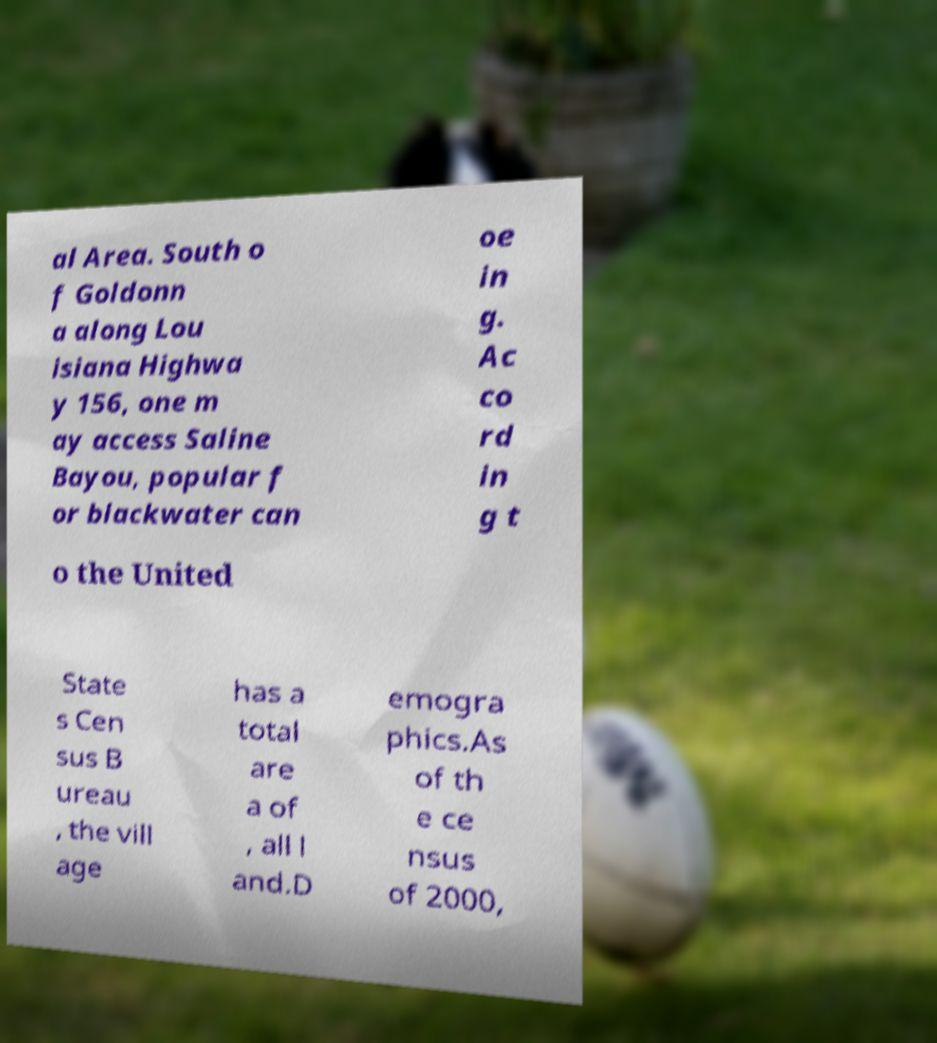Could you extract and type out the text from this image? al Area. South o f Goldonn a along Lou isiana Highwa y 156, one m ay access Saline Bayou, popular f or blackwater can oe in g. Ac co rd in g t o the United State s Cen sus B ureau , the vill age has a total are a of , all l and.D emogra phics.As of th e ce nsus of 2000, 